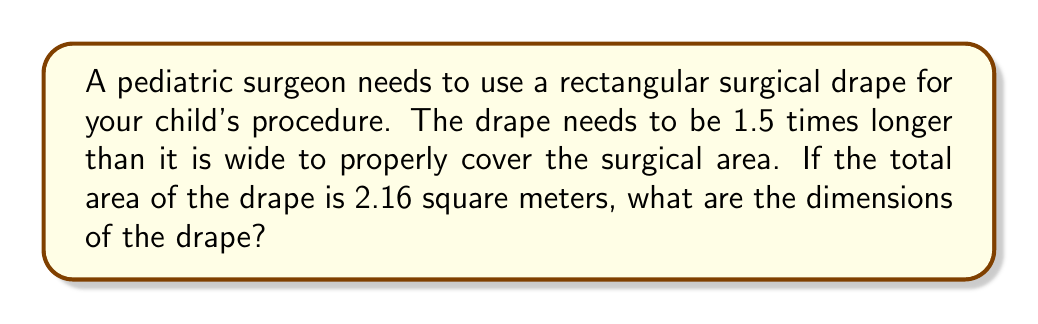Can you answer this question? Let's approach this step-by-step:

1) Let's define our variables:
   $w$ = width of the drape
   $l$ = length of the drape

2) We're told that the length is 1.5 times the width:
   $l = 1.5w$

3) The area of a rectangle is length times width:
   $A = l \times w$

4) We're given that the area is 2.16 square meters:
   $2.16 = l \times w$

5) Substituting the expression for $l$ from step 2:
   $2.16 = 1.5w \times w = 1.5w^2$

6) Now we can solve for $w$:
   $$\begin{align}
   1.5w^2 &= 2.16 \\
   w^2 &= 2.16 \div 1.5 = 1.44 \\
   w &= \sqrt{1.44} = 1.2 \text{ meters}
   \end{align}$$

7) Now that we know the width, we can calculate the length:
   $l = 1.5w = 1.5 \times 1.2 = 1.8 \text{ meters}$

Therefore, the dimensions of the drape are 1.2 meters wide by 1.8 meters long.
Answer: The dimensions of the surgical drape are 1.2 meters wide and 1.8 meters long. 